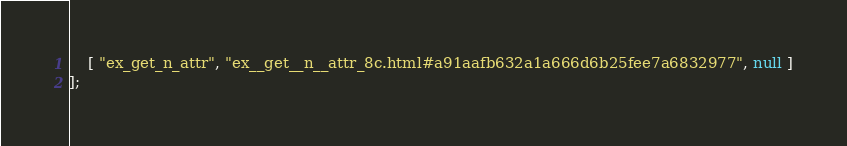Convert code to text. <code><loc_0><loc_0><loc_500><loc_500><_JavaScript_>    [ "ex_get_n_attr", "ex__get__n__attr_8c.html#a91aafb632a1a666d6b25fee7a6832977", null ]
];</code> 